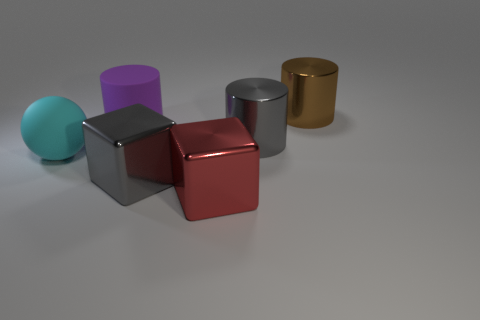Subtract all brown cylinders. How many cylinders are left? 2 Add 3 large brown cubes. How many objects exist? 9 Subtract all gray cubes. How many cubes are left? 1 Subtract all spheres. How many objects are left? 5 Subtract 1 cylinders. How many cylinders are left? 2 Add 2 tiny yellow shiny cylinders. How many tiny yellow shiny cylinders exist? 2 Subtract 0 purple cubes. How many objects are left? 6 Subtract all yellow spheres. Subtract all gray cubes. How many spheres are left? 1 Subtract all brown cubes. How many purple cylinders are left? 1 Subtract all small rubber cylinders. Subtract all matte cylinders. How many objects are left? 5 